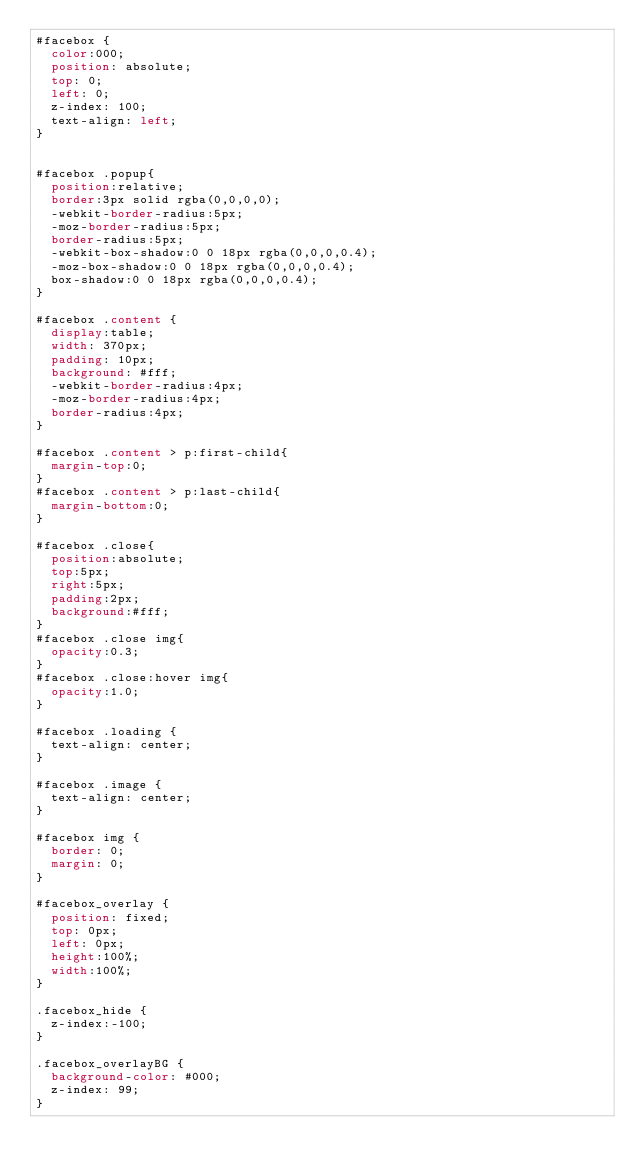<code> <loc_0><loc_0><loc_500><loc_500><_CSS_>#facebox {
  color:000;
  position: absolute;
  top: 0;
  left: 0;
  z-index: 100;
  text-align: left;
}


#facebox .popup{
  position:relative;
  border:3px solid rgba(0,0,0,0);
  -webkit-border-radius:5px;
  -moz-border-radius:5px;
  border-radius:5px;
  -webkit-box-shadow:0 0 18px rgba(0,0,0,0.4);
  -moz-box-shadow:0 0 18px rgba(0,0,0,0.4);
  box-shadow:0 0 18px rgba(0,0,0,0.4);
}

#facebox .content {
  display:table;
  width: 370px;
  padding: 10px;
  background: #fff;
  -webkit-border-radius:4px;
  -moz-border-radius:4px;
  border-radius:4px;
}

#facebox .content > p:first-child{
  margin-top:0;
}
#facebox .content > p:last-child{
  margin-bottom:0;
}

#facebox .close{
  position:absolute;
  top:5px;
  right:5px;
  padding:2px;
  background:#fff;
}
#facebox .close img{
  opacity:0.3;
}
#facebox .close:hover img{
  opacity:1.0;
}

#facebox .loading {
  text-align: center;
}

#facebox .image {
  text-align: center;
}

#facebox img {
  border: 0;
  margin: 0;
}

#facebox_overlay {
  position: fixed;
  top: 0px;
  left: 0px;
  height:100%;
  width:100%;
}

.facebox_hide {
  z-index:-100;
}

.facebox_overlayBG {
  background-color: #000;
  z-index: 99;
}</code> 